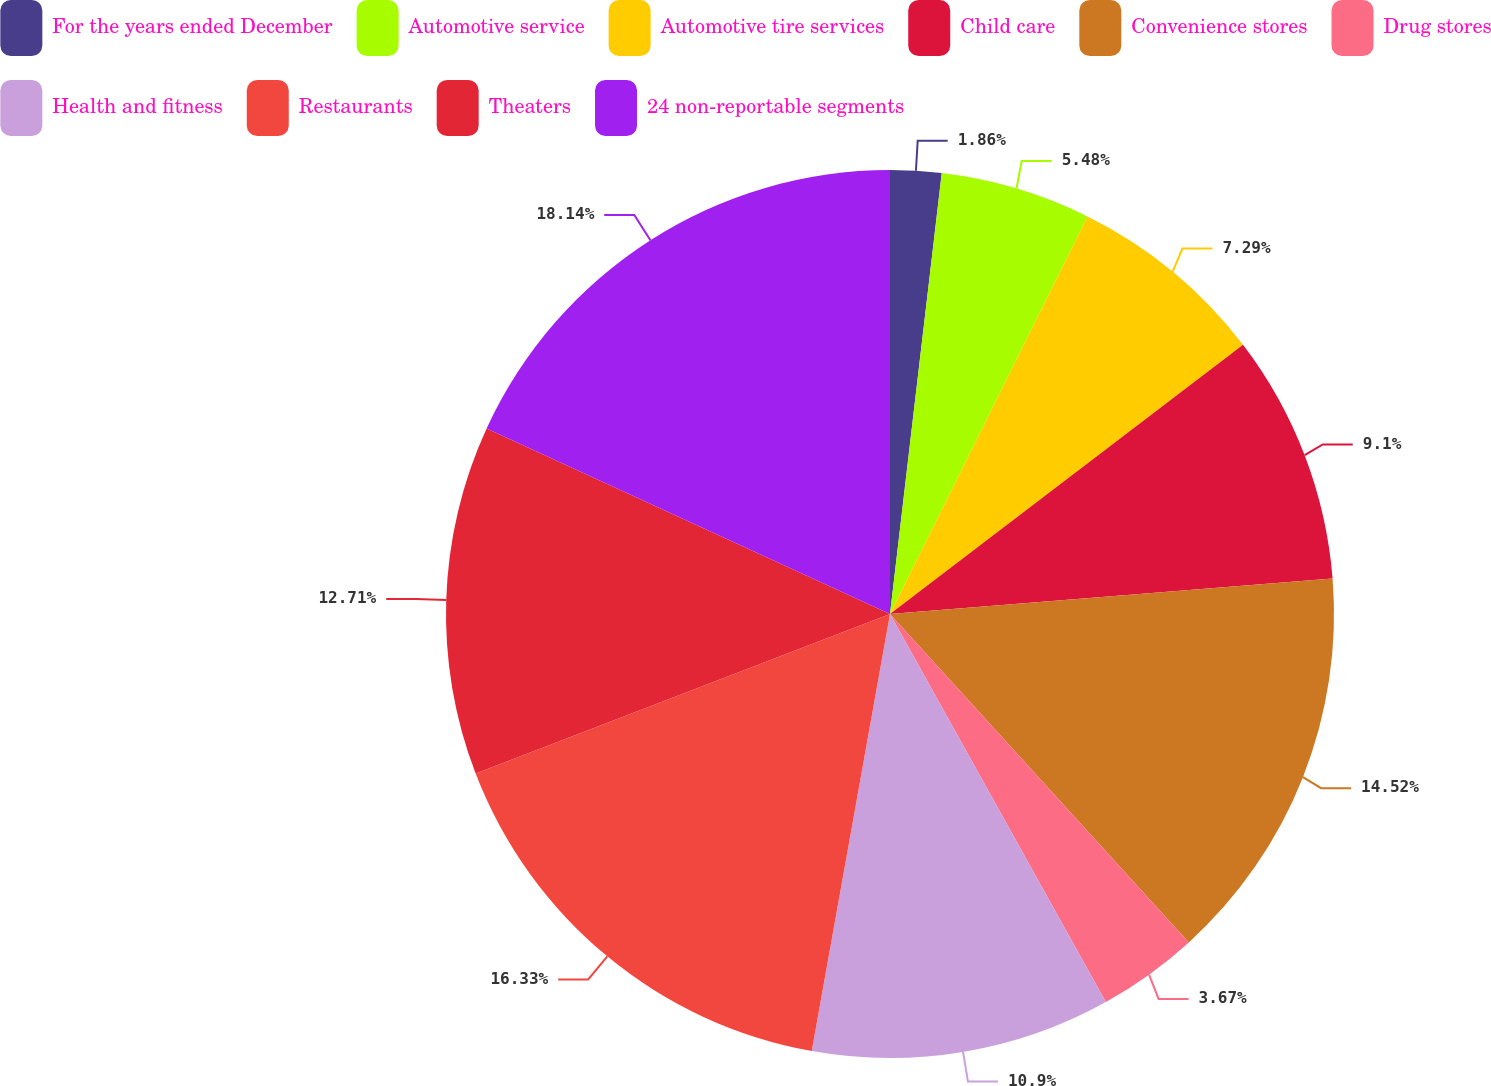<chart> <loc_0><loc_0><loc_500><loc_500><pie_chart><fcel>For the years ended December<fcel>Automotive service<fcel>Automotive tire services<fcel>Child care<fcel>Convenience stores<fcel>Drug stores<fcel>Health and fitness<fcel>Restaurants<fcel>Theaters<fcel>24 non-reportable segments<nl><fcel>1.86%<fcel>5.48%<fcel>7.29%<fcel>9.1%<fcel>14.52%<fcel>3.67%<fcel>10.9%<fcel>16.33%<fcel>12.71%<fcel>18.14%<nl></chart> 